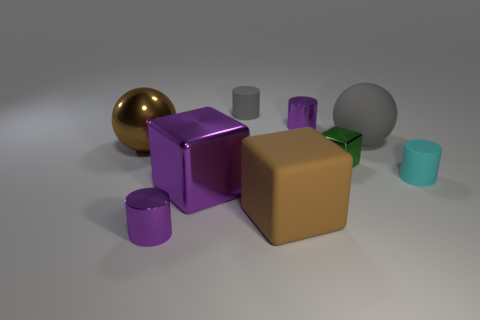What is the size of the matte block that is the same color as the shiny ball?
Provide a short and direct response. Large. Is the color of the big metallic block the same as the matte ball?
Ensure brevity in your answer.  No. Is the size of the gray cylinder the same as the brown cube?
Keep it short and to the point. No. Do the big sphere that is in front of the matte sphere and the rubber ball have the same color?
Keep it short and to the point. No. How many large metal things are behind the large shiny cube?
Offer a terse response. 1. Are there more large blue rubber cylinders than matte blocks?
Make the answer very short. No. There is a big thing that is to the right of the big brown metal object and behind the small cyan cylinder; what is its shape?
Offer a terse response. Sphere. Are any cyan rubber cylinders visible?
Ensure brevity in your answer.  Yes. There is a brown thing that is the same shape as the big gray object; what is its material?
Your answer should be very brief. Metal. What is the shape of the big brown thing in front of the sphere left of the small shiny cylinder on the left side of the purple metallic cube?
Offer a terse response. Cube. 